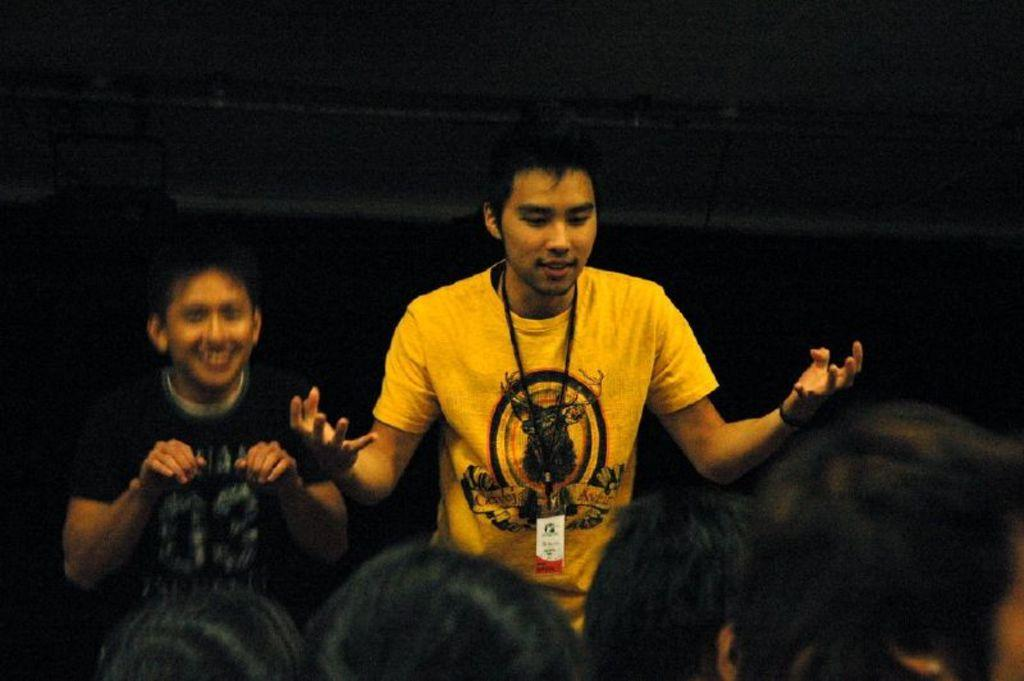How many people are standing in the image? There are two men standing in the image. What color is the t-shirt of one of the men? One person is wearing a yellow t-shirt. Can you describe the position of the people's heads in the image? People's heads are visible at the bottom of the image. What type of fly is sitting on the brain of the person wearing the yellow t-shirt? There is no fly or brain present in the image. 